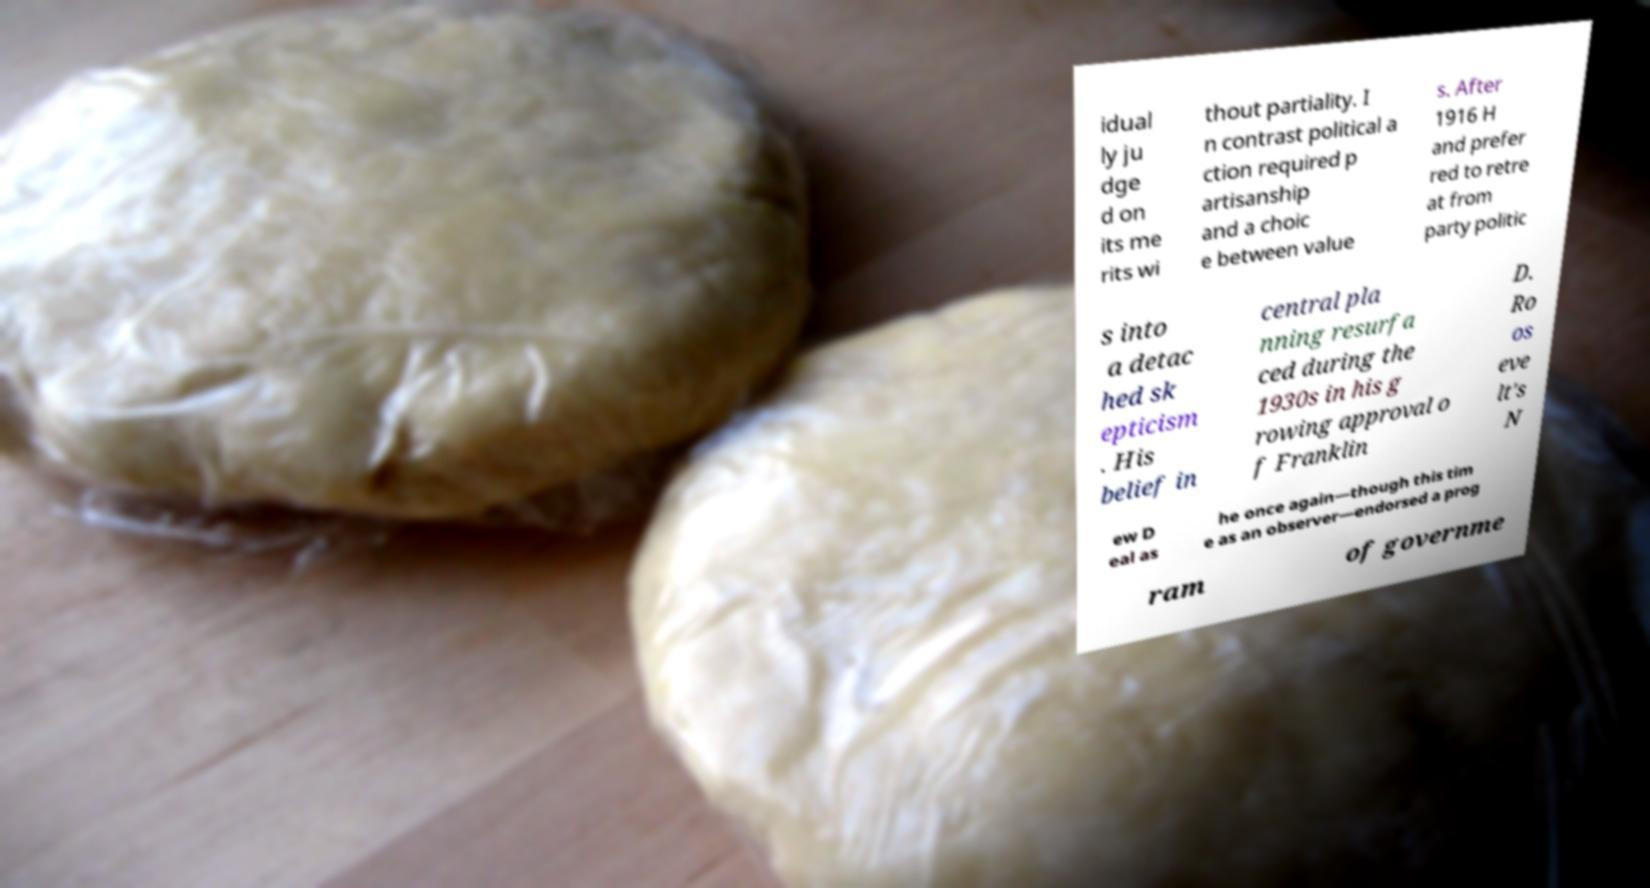Please identify and transcribe the text found in this image. idual ly ju dge d on its me rits wi thout partiality. I n contrast political a ction required p artisanship and a choic e between value s. After 1916 H and prefer red to retre at from party politic s into a detac hed sk epticism . His belief in central pla nning resurfa ced during the 1930s in his g rowing approval o f Franklin D. Ro os eve lt's N ew D eal as he once again—though this tim e as an observer—endorsed a prog ram of governme 